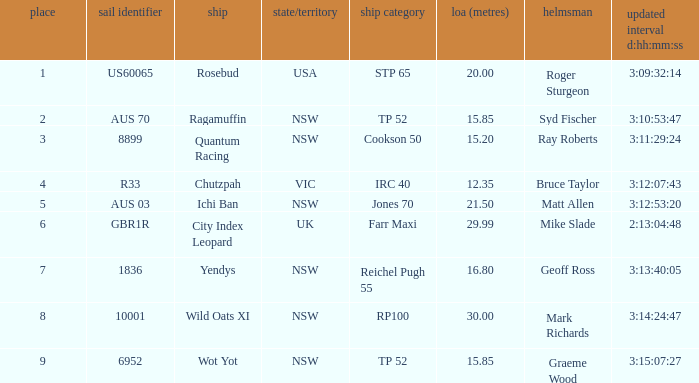Help me parse the entirety of this table. {'header': ['place', 'sail identifier', 'ship', 'state/territory', 'ship category', 'loa (metres)', 'helmsman', 'updated interval d:hh:mm:ss'], 'rows': [['1', 'US60065', 'Rosebud', 'USA', 'STP 65', '20.00', 'Roger Sturgeon', '3:09:32:14'], ['2', 'AUS 70', 'Ragamuffin', 'NSW', 'TP 52', '15.85', 'Syd Fischer', '3:10:53:47'], ['3', '8899', 'Quantum Racing', 'NSW', 'Cookson 50', '15.20', 'Ray Roberts', '3:11:29:24'], ['4', 'R33', 'Chutzpah', 'VIC', 'IRC 40', '12.35', 'Bruce Taylor', '3:12:07:43'], ['5', 'AUS 03', 'Ichi Ban', 'NSW', 'Jones 70', '21.50', 'Matt Allen', '3:12:53:20'], ['6', 'GBR1R', 'City Index Leopard', 'UK', 'Farr Maxi', '29.99', 'Mike Slade', '2:13:04:48'], ['7', '1836', 'Yendys', 'NSW', 'Reichel Pugh 55', '16.80', 'Geoff Ross', '3:13:40:05'], ['8', '10001', 'Wild Oats XI', 'NSW', 'RP100', '30.00', 'Mark Richards', '3:14:24:47'], ['9', '6952', 'Wot Yot', 'NSW', 'TP 52', '15.85', 'Graeme Wood', '3:15:07:27']]} Who were all of the skippers with a corrected time of 3:15:07:27? Graeme Wood. 